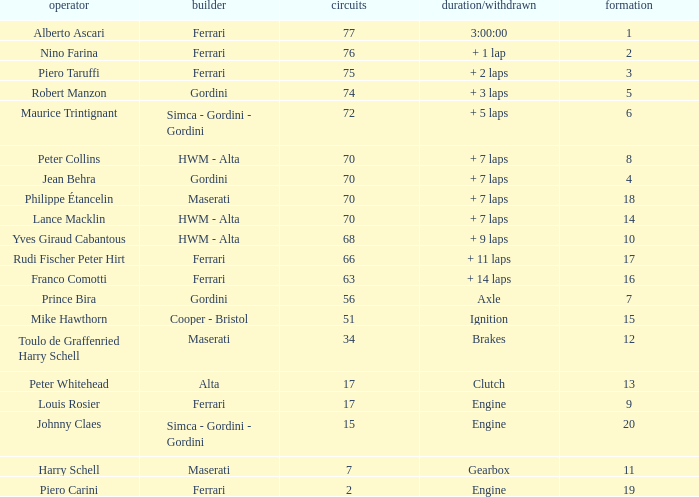How many grids for peter collins? 1.0. 